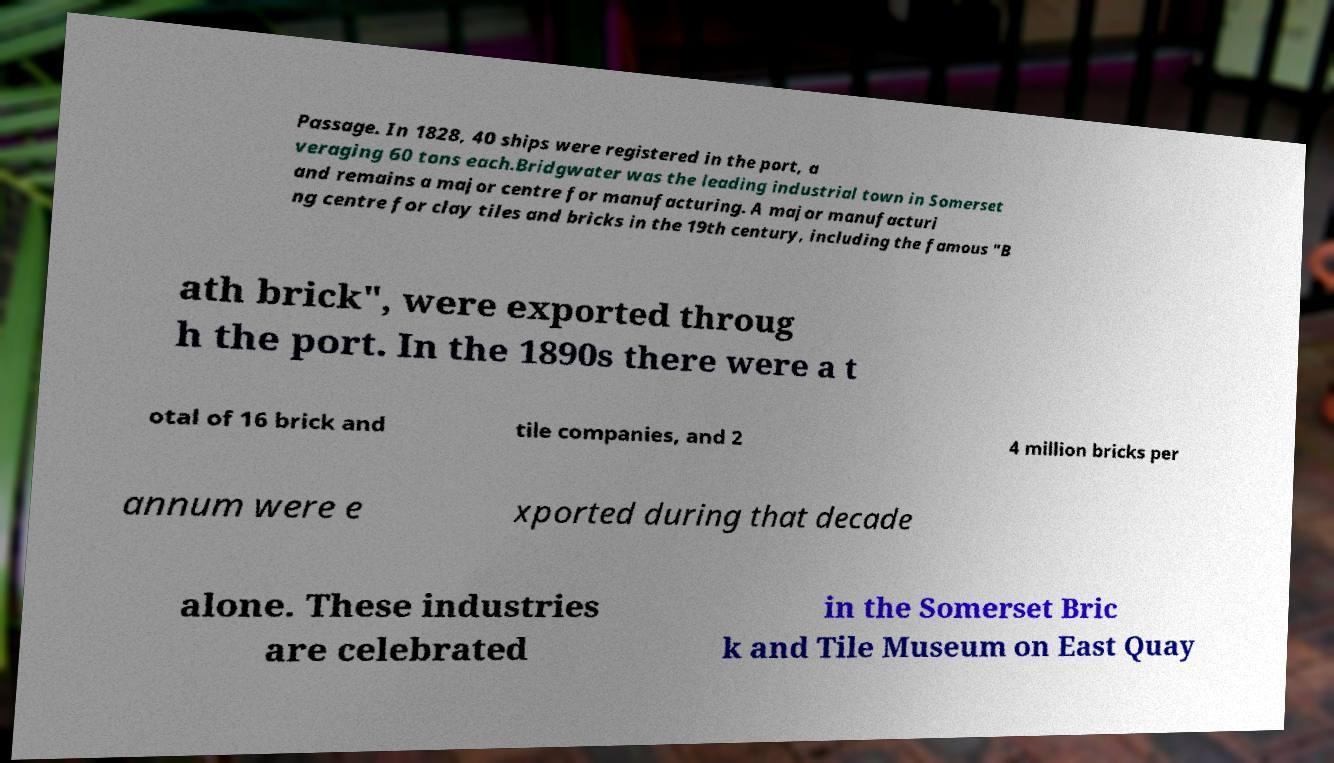What messages or text are displayed in this image? I need them in a readable, typed format. Passage. In 1828, 40 ships were registered in the port, a veraging 60 tons each.Bridgwater was the leading industrial town in Somerset and remains a major centre for manufacturing. A major manufacturi ng centre for clay tiles and bricks in the 19th century, including the famous "B ath brick", were exported throug h the port. In the 1890s there were a t otal of 16 brick and tile companies, and 2 4 million bricks per annum were e xported during that decade alone. These industries are celebrated in the Somerset Bric k and Tile Museum on East Quay 